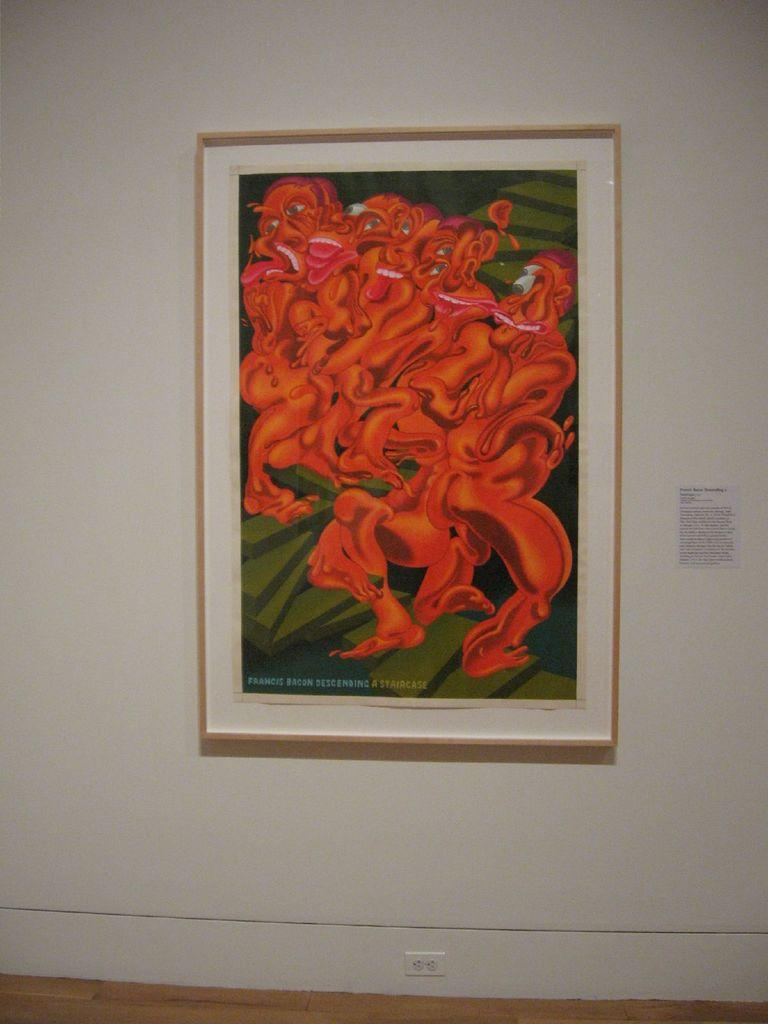What is the main object in the image? There is a frame in the image. What is hanging on the wall in the image? There is a poster on the wall in the image. Reasoning: Let' Let's think step by step in order to produce the conversation. We start by identifying the main object in the image, which is the frame. Then, we expand the conversation to include the poster on the wall, which is another important element in the image. Each question is designed to elicit a specific detail about the image that is known from the provided facts. Absurd Question/Answer: What type of flower is growing on the flag in the image? There is no flag or flower present in the image. 